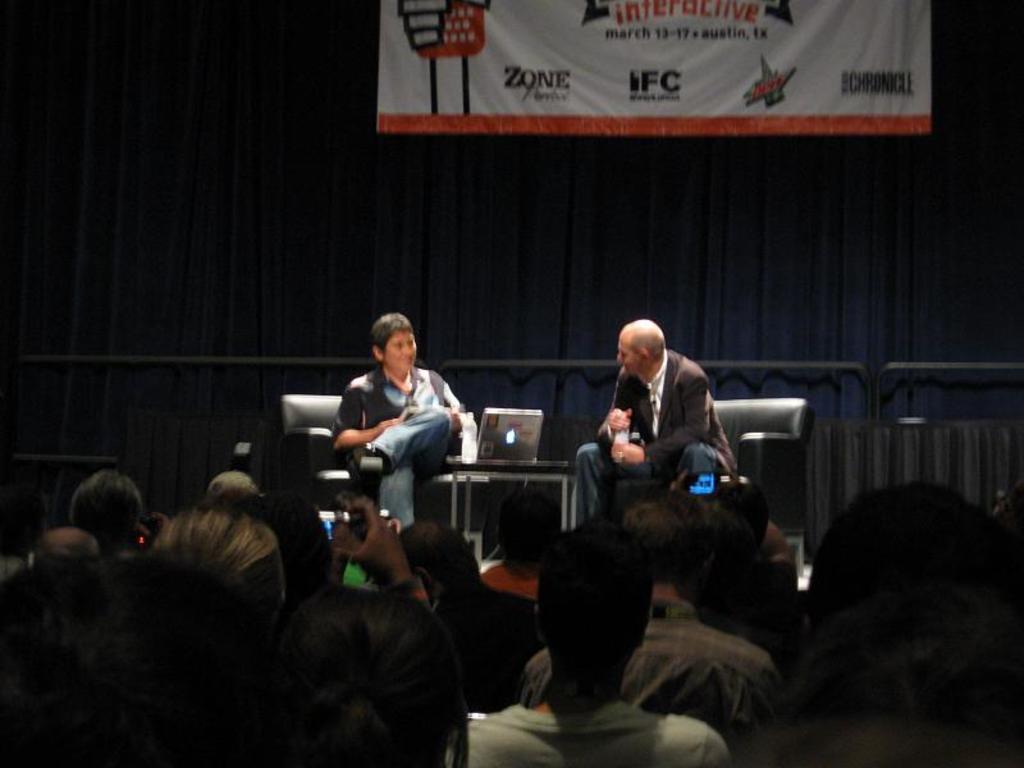Could you give a brief overview of what you see in this image? In this picture there are two men sitting on the sofa and discussing something. In between there is a table and laptop. In the front bottom side there are some persons sitting and taking a photos. Behind there is a black curtains and white color hanging banner. 